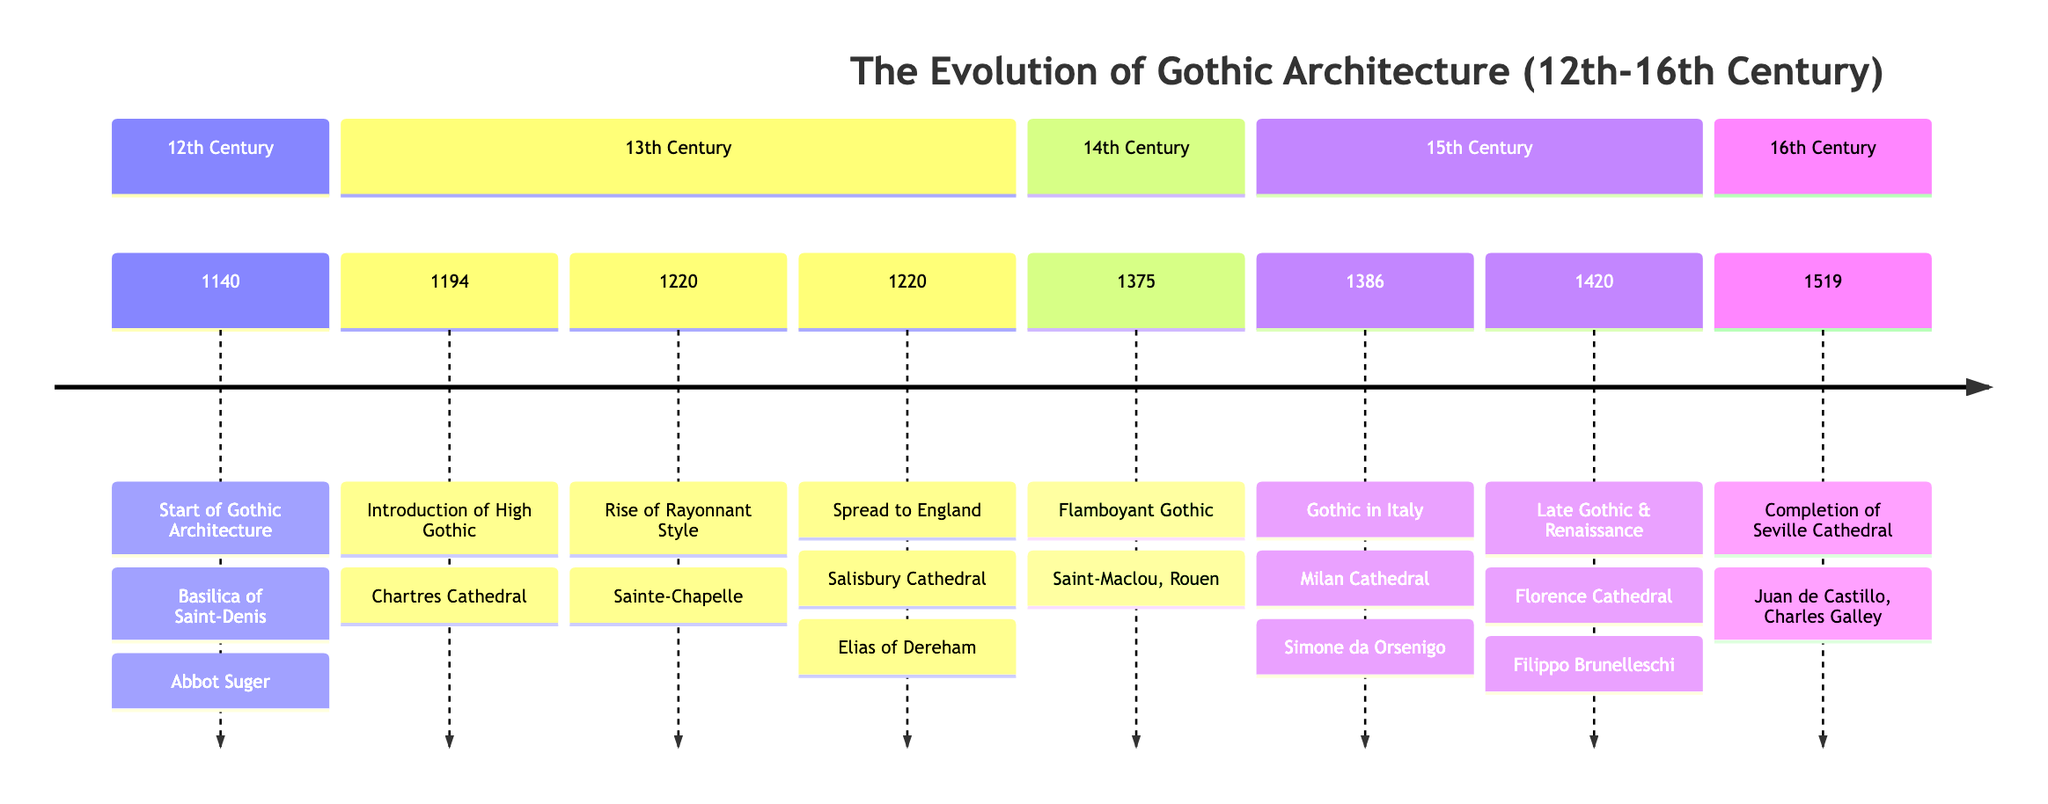What year did the Gothic style begin? The diagram indicates that the Gothic style begins in 1140 with the construction of the Basilica of Saint-Denis.
Answer: 1140 Who was the architect of the Basilica of Saint-Denis? According to the timeline, Abbot Suger is identified as the architect associated with the Basilica of Saint-Denis built in 1140.
Answer: Abbot Suger Which significant structure marks the introduction of High Gothic architecture? The timeline specifies Chartres Cathedral as the significant structure related to the introduction of High Gothic architecture in 1194.
Answer: Chartres Cathedral When did the Flamboyant Gothic style become popular? The diagram states that the Flamboyant Gothic style became popular in 1375, signifying its evolution in that year.
Answer: 1375 What architectural feature is emphasized in the Rayonnant Gothic style? The annotations for Sainte-Chapelle highlight the extensive use of stained glass as a key feature of the Rayonnant Gothic style that emerged around 1220.
Answer: Extensive use of stained glass What is the significance of Florence Cathedral in relation to the Late Gothic period? The timeline notes that Florence Cathedral reflects a blending of Gothic and early Renaissance elements, indicating its significance during the Late Gothic period in 1420.
Answer: Blending of Gothic and early Renaissance elements How did Gothic architecture spread to England? The timeline illustrates that Gothic architecture spread to England exemplified by the construction of Salisbury Cathedral, built in 1220 by Elias of Dereham.
Answer: Salisbury Cathedral Which cathedral is mentioned as the largest Gothic structure completed in 1519? The timeline explicitly mentions that Seville Cathedral is the largest Gothic cathedral completed in 1519.
Answer: Seville Cathedral What year marks the beginning of the construction of Milan Cathedral? According to the timeline, the construction of Milan Cathedral began in 1386 as part of the spread of Gothic architecture to Italy.
Answer: 1386 